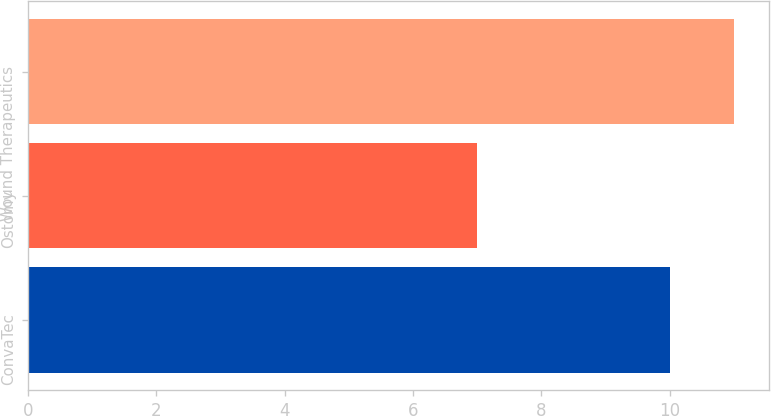Convert chart. <chart><loc_0><loc_0><loc_500><loc_500><bar_chart><fcel>ConvaTec<fcel>Ostomy<fcel>Wound Therapeutics<nl><fcel>10<fcel>7<fcel>11<nl></chart> 